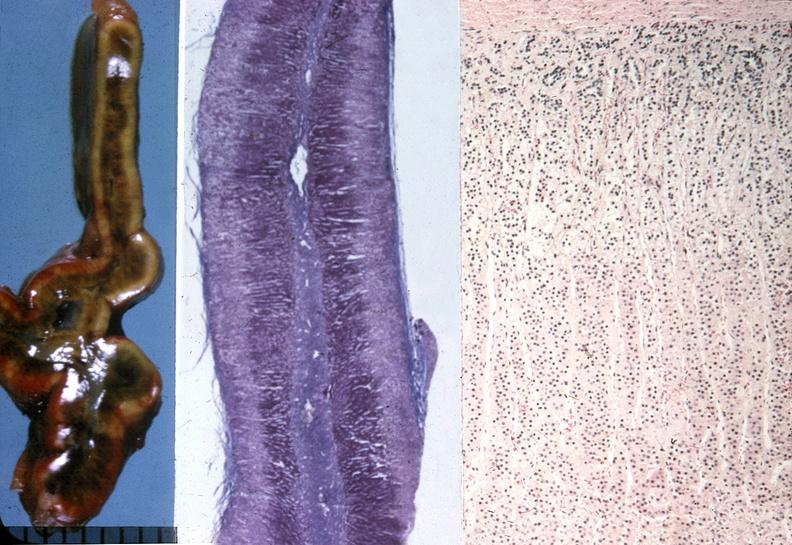s endocrine present?
Answer the question using a single word or phrase. Yes 